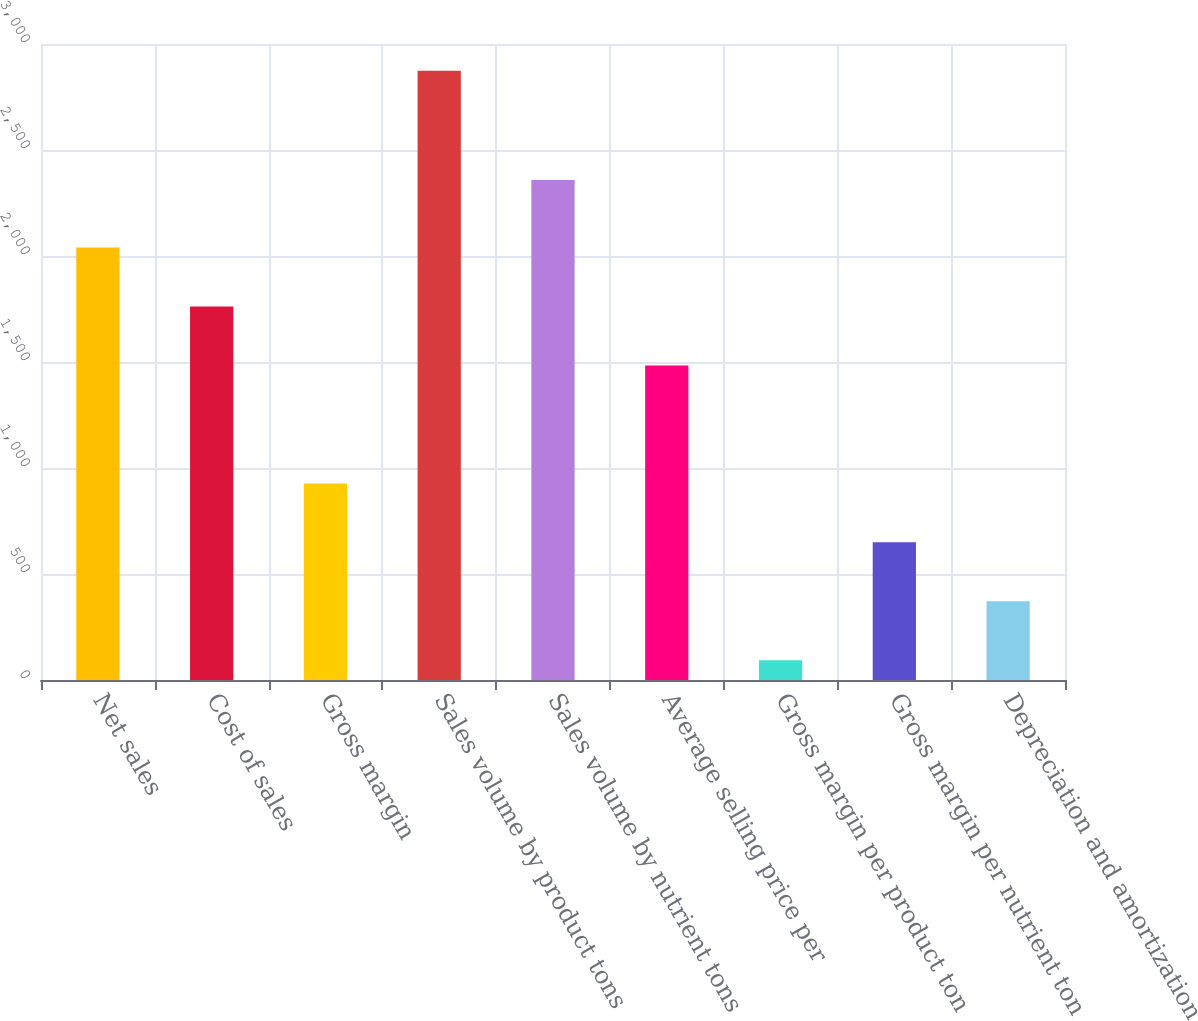Convert chart. <chart><loc_0><loc_0><loc_500><loc_500><bar_chart><fcel>Net sales<fcel>Cost of sales<fcel>Gross margin<fcel>Sales volume by product tons<fcel>Sales volume by nutrient tons<fcel>Average selling price per<fcel>Gross margin per product ton<fcel>Gross margin per nutrient ton<fcel>Depreciation and amortization<nl><fcel>2039.7<fcel>1761.6<fcel>927.3<fcel>2874<fcel>2358<fcel>1483.5<fcel>93<fcel>649.2<fcel>371.1<nl></chart> 